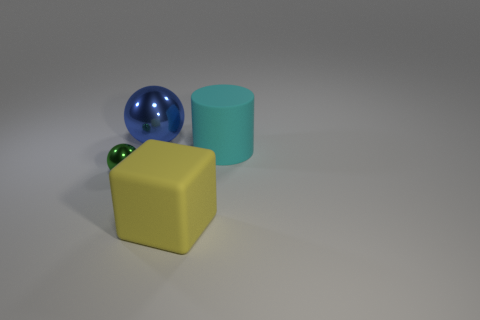How many large objects are rubber objects or green objects? In the image, there are three large objects. Among these, we have one green cylindrical object, which satisfies the condition of being green. The yellow cube and the blue sphere do not meet the green criterion, and without specific information on the materials, it's not possible to determine if any are made of rubber. Therefore, based on the visible information, there is only 1 object that is clearly green—a large green cylinder. 